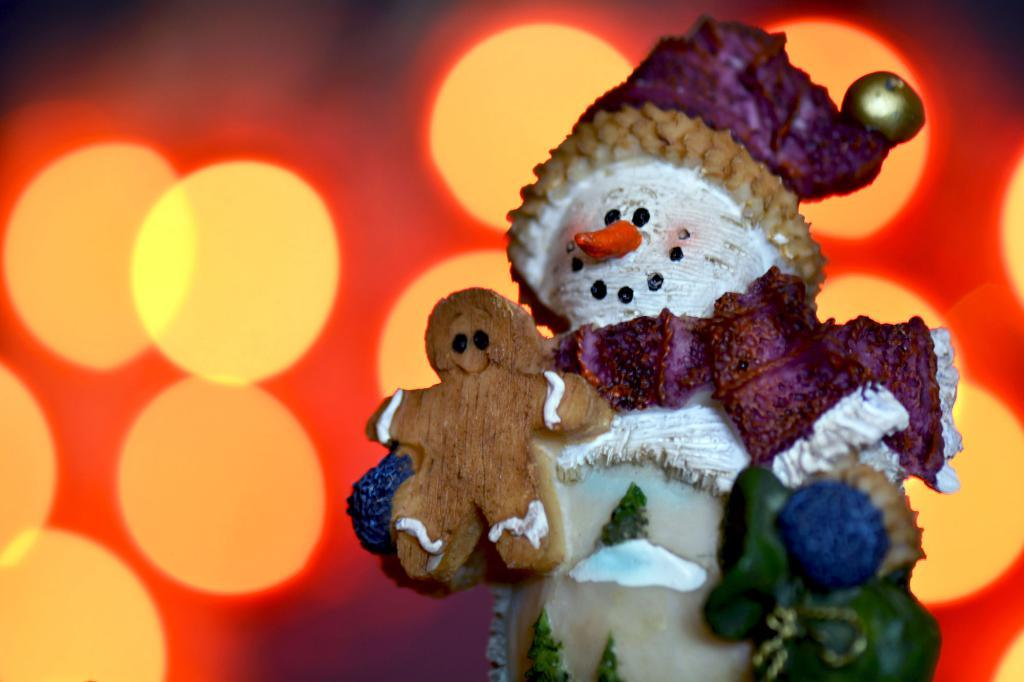What is the main subject of the image? There is a sculpture of a joker in the image. What is the joker sculpture holding? The joker sculpture is holding a teddy bear. How close is the camera to the subject in the image? The image is zoomed in. What can be seen in the background of the image? There are lights visible in the background of the image. Can you tell me how many cans are visible in the image? There are no cans present in the image; it features a sculpture of a joker holding a teddy bear. Is there a bike visible in the image? No, there is no bike present in the image. 